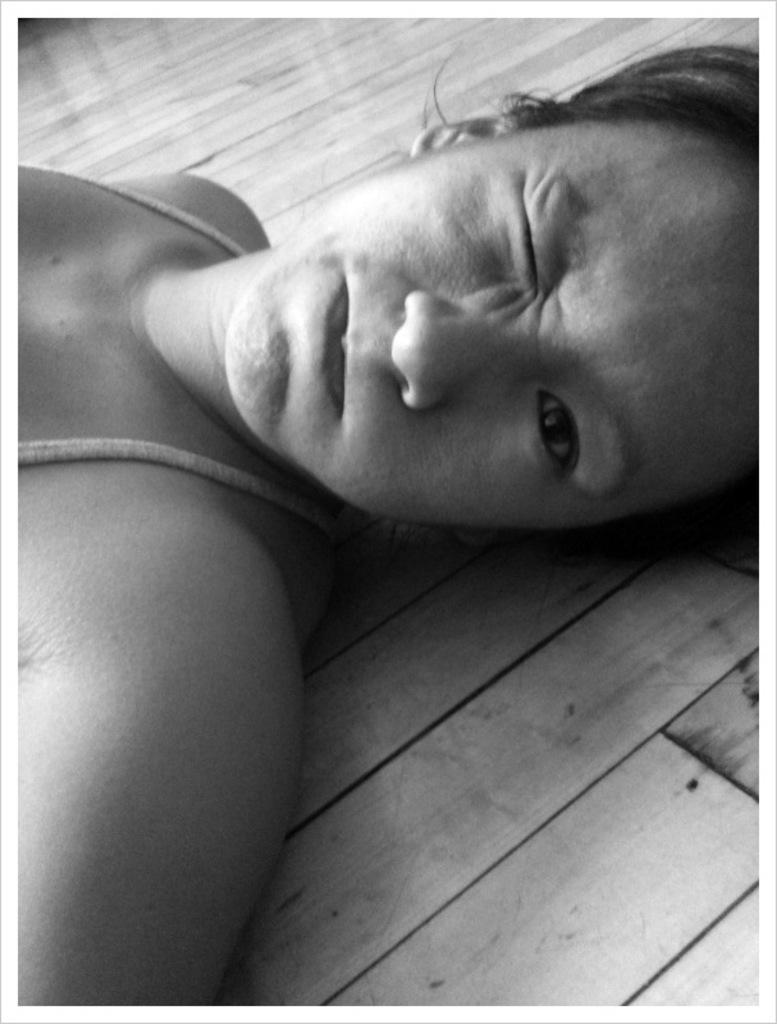Please provide a concise description of this image. In the middle of this image, there is a woman lying on a wooden surface. 